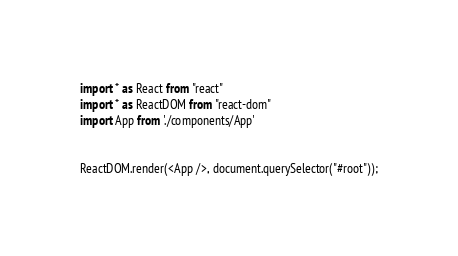Convert code to text. <code><loc_0><loc_0><loc_500><loc_500><_TypeScript_>import * as React from "react"
import * as ReactDOM from "react-dom"
import App from './components/App'


ReactDOM.render(<App />, document.querySelector("#root"));
</code> 